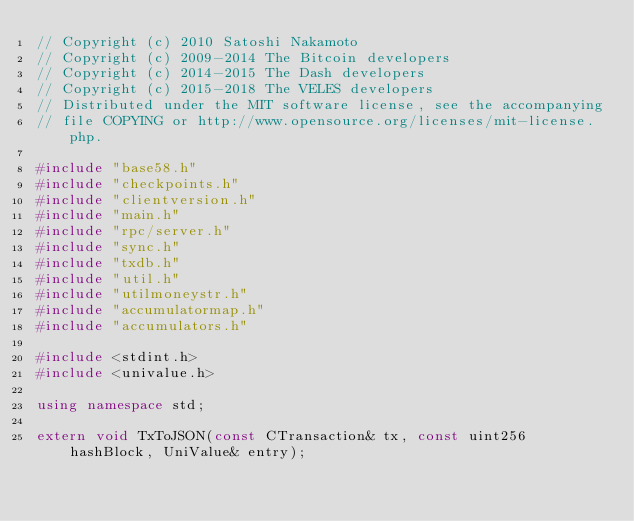Convert code to text. <code><loc_0><loc_0><loc_500><loc_500><_C++_>// Copyright (c) 2010 Satoshi Nakamoto
// Copyright (c) 2009-2014 The Bitcoin developers
// Copyright (c) 2014-2015 The Dash developers
// Copyright (c) 2015-2018 The VELES developers
// Distributed under the MIT software license, see the accompanying
// file COPYING or http://www.opensource.org/licenses/mit-license.php.

#include "base58.h"
#include "checkpoints.h"
#include "clientversion.h"
#include "main.h"
#include "rpc/server.h"
#include "sync.h"
#include "txdb.h"
#include "util.h"
#include "utilmoneystr.h"
#include "accumulatormap.h"
#include "accumulators.h"

#include <stdint.h>
#include <univalue.h>

using namespace std;

extern void TxToJSON(const CTransaction& tx, const uint256 hashBlock, UniValue& entry);</code> 